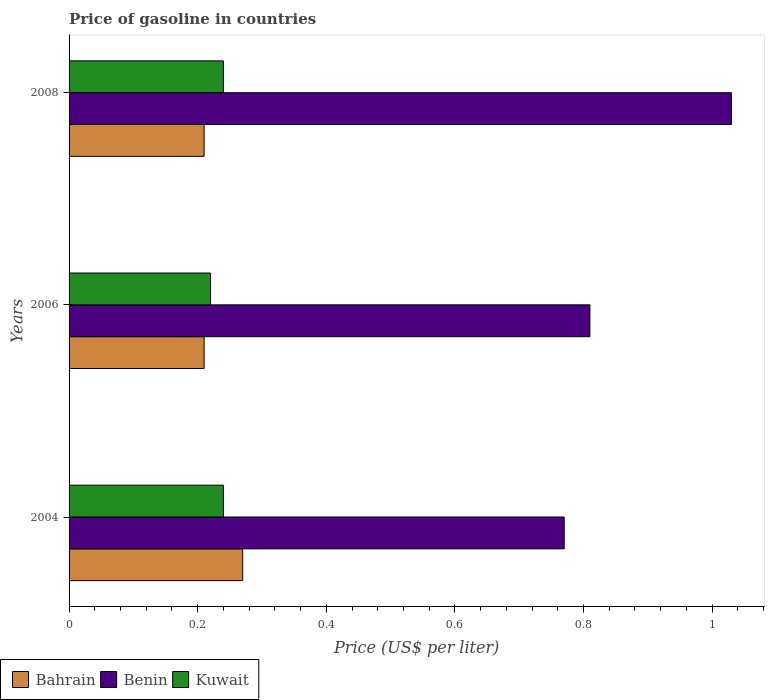Are the number of bars on each tick of the Y-axis equal?
Your response must be concise. Yes. How many bars are there on the 2nd tick from the top?
Offer a terse response. 3. How many bars are there on the 1st tick from the bottom?
Your answer should be compact. 3. What is the label of the 1st group of bars from the top?
Your answer should be compact. 2008. In how many cases, is the number of bars for a given year not equal to the number of legend labels?
Ensure brevity in your answer.  0. Across all years, what is the maximum price of gasoline in Kuwait?
Provide a short and direct response. 0.24. Across all years, what is the minimum price of gasoline in Benin?
Offer a very short reply. 0.77. In which year was the price of gasoline in Kuwait maximum?
Provide a short and direct response. 2004. What is the total price of gasoline in Benin in the graph?
Offer a very short reply. 2.61. What is the difference between the price of gasoline in Kuwait in 2004 and the price of gasoline in Benin in 2006?
Offer a terse response. -0.57. What is the average price of gasoline in Kuwait per year?
Ensure brevity in your answer.  0.23. In the year 2008, what is the difference between the price of gasoline in Benin and price of gasoline in Bahrain?
Keep it short and to the point. 0.82. What is the ratio of the price of gasoline in Bahrain in 2004 to that in 2006?
Your answer should be compact. 1.29. Is the price of gasoline in Bahrain in 2004 less than that in 2006?
Your answer should be very brief. No. Is the difference between the price of gasoline in Benin in 2004 and 2008 greater than the difference between the price of gasoline in Bahrain in 2004 and 2008?
Ensure brevity in your answer.  No. What is the difference between the highest and the second highest price of gasoline in Bahrain?
Make the answer very short. 0.06. What is the difference between the highest and the lowest price of gasoline in Benin?
Provide a short and direct response. 0.26. Is the sum of the price of gasoline in Benin in 2004 and 2006 greater than the maximum price of gasoline in Kuwait across all years?
Offer a terse response. Yes. What does the 2nd bar from the top in 2008 represents?
Ensure brevity in your answer.  Benin. What does the 3rd bar from the bottom in 2008 represents?
Provide a short and direct response. Kuwait. Does the graph contain any zero values?
Make the answer very short. No. Where does the legend appear in the graph?
Your answer should be compact. Bottom left. How many legend labels are there?
Keep it short and to the point. 3. How are the legend labels stacked?
Give a very brief answer. Horizontal. What is the title of the graph?
Provide a short and direct response. Price of gasoline in countries. What is the label or title of the X-axis?
Your answer should be compact. Price (US$ per liter). What is the Price (US$ per liter) in Bahrain in 2004?
Give a very brief answer. 0.27. What is the Price (US$ per liter) of Benin in 2004?
Provide a short and direct response. 0.77. What is the Price (US$ per liter) of Kuwait in 2004?
Your answer should be compact. 0.24. What is the Price (US$ per liter) in Bahrain in 2006?
Ensure brevity in your answer.  0.21. What is the Price (US$ per liter) in Benin in 2006?
Your response must be concise. 0.81. What is the Price (US$ per liter) in Kuwait in 2006?
Your answer should be compact. 0.22. What is the Price (US$ per liter) in Bahrain in 2008?
Provide a succinct answer. 0.21. What is the Price (US$ per liter) of Benin in 2008?
Your response must be concise. 1.03. What is the Price (US$ per liter) in Kuwait in 2008?
Offer a very short reply. 0.24. Across all years, what is the maximum Price (US$ per liter) in Bahrain?
Ensure brevity in your answer.  0.27. Across all years, what is the maximum Price (US$ per liter) of Benin?
Your answer should be very brief. 1.03. Across all years, what is the maximum Price (US$ per liter) of Kuwait?
Your answer should be compact. 0.24. Across all years, what is the minimum Price (US$ per liter) of Bahrain?
Offer a very short reply. 0.21. Across all years, what is the minimum Price (US$ per liter) of Benin?
Make the answer very short. 0.77. Across all years, what is the minimum Price (US$ per liter) of Kuwait?
Keep it short and to the point. 0.22. What is the total Price (US$ per liter) in Bahrain in the graph?
Provide a short and direct response. 0.69. What is the total Price (US$ per liter) in Benin in the graph?
Make the answer very short. 2.61. What is the total Price (US$ per liter) in Kuwait in the graph?
Your answer should be compact. 0.7. What is the difference between the Price (US$ per liter) of Bahrain in 2004 and that in 2006?
Your answer should be very brief. 0.06. What is the difference between the Price (US$ per liter) in Benin in 2004 and that in 2006?
Provide a short and direct response. -0.04. What is the difference between the Price (US$ per liter) of Benin in 2004 and that in 2008?
Give a very brief answer. -0.26. What is the difference between the Price (US$ per liter) in Kuwait in 2004 and that in 2008?
Keep it short and to the point. 0. What is the difference between the Price (US$ per liter) in Bahrain in 2006 and that in 2008?
Offer a terse response. 0. What is the difference between the Price (US$ per liter) of Benin in 2006 and that in 2008?
Provide a succinct answer. -0.22. What is the difference between the Price (US$ per liter) in Kuwait in 2006 and that in 2008?
Offer a terse response. -0.02. What is the difference between the Price (US$ per liter) in Bahrain in 2004 and the Price (US$ per liter) in Benin in 2006?
Your response must be concise. -0.54. What is the difference between the Price (US$ per liter) in Benin in 2004 and the Price (US$ per liter) in Kuwait in 2006?
Make the answer very short. 0.55. What is the difference between the Price (US$ per liter) of Bahrain in 2004 and the Price (US$ per liter) of Benin in 2008?
Keep it short and to the point. -0.76. What is the difference between the Price (US$ per liter) in Bahrain in 2004 and the Price (US$ per liter) in Kuwait in 2008?
Offer a very short reply. 0.03. What is the difference between the Price (US$ per liter) in Benin in 2004 and the Price (US$ per liter) in Kuwait in 2008?
Provide a succinct answer. 0.53. What is the difference between the Price (US$ per liter) of Bahrain in 2006 and the Price (US$ per liter) of Benin in 2008?
Ensure brevity in your answer.  -0.82. What is the difference between the Price (US$ per liter) in Bahrain in 2006 and the Price (US$ per liter) in Kuwait in 2008?
Offer a very short reply. -0.03. What is the difference between the Price (US$ per liter) in Benin in 2006 and the Price (US$ per liter) in Kuwait in 2008?
Your answer should be very brief. 0.57. What is the average Price (US$ per liter) of Bahrain per year?
Your answer should be compact. 0.23. What is the average Price (US$ per liter) in Benin per year?
Make the answer very short. 0.87. What is the average Price (US$ per liter) of Kuwait per year?
Make the answer very short. 0.23. In the year 2004, what is the difference between the Price (US$ per liter) in Bahrain and Price (US$ per liter) in Benin?
Keep it short and to the point. -0.5. In the year 2004, what is the difference between the Price (US$ per liter) of Bahrain and Price (US$ per liter) of Kuwait?
Keep it short and to the point. 0.03. In the year 2004, what is the difference between the Price (US$ per liter) of Benin and Price (US$ per liter) of Kuwait?
Your answer should be very brief. 0.53. In the year 2006, what is the difference between the Price (US$ per liter) in Bahrain and Price (US$ per liter) in Kuwait?
Make the answer very short. -0.01. In the year 2006, what is the difference between the Price (US$ per liter) in Benin and Price (US$ per liter) in Kuwait?
Provide a short and direct response. 0.59. In the year 2008, what is the difference between the Price (US$ per liter) of Bahrain and Price (US$ per liter) of Benin?
Provide a succinct answer. -0.82. In the year 2008, what is the difference between the Price (US$ per liter) in Bahrain and Price (US$ per liter) in Kuwait?
Your answer should be compact. -0.03. In the year 2008, what is the difference between the Price (US$ per liter) in Benin and Price (US$ per liter) in Kuwait?
Give a very brief answer. 0.79. What is the ratio of the Price (US$ per liter) in Bahrain in 2004 to that in 2006?
Ensure brevity in your answer.  1.29. What is the ratio of the Price (US$ per liter) in Benin in 2004 to that in 2006?
Make the answer very short. 0.95. What is the ratio of the Price (US$ per liter) of Kuwait in 2004 to that in 2006?
Make the answer very short. 1.09. What is the ratio of the Price (US$ per liter) in Benin in 2004 to that in 2008?
Offer a terse response. 0.75. What is the ratio of the Price (US$ per liter) of Bahrain in 2006 to that in 2008?
Your response must be concise. 1. What is the ratio of the Price (US$ per liter) in Benin in 2006 to that in 2008?
Your response must be concise. 0.79. What is the ratio of the Price (US$ per liter) in Kuwait in 2006 to that in 2008?
Ensure brevity in your answer.  0.92. What is the difference between the highest and the second highest Price (US$ per liter) in Benin?
Ensure brevity in your answer.  0.22. What is the difference between the highest and the lowest Price (US$ per liter) of Bahrain?
Your answer should be compact. 0.06. What is the difference between the highest and the lowest Price (US$ per liter) of Benin?
Give a very brief answer. 0.26. 